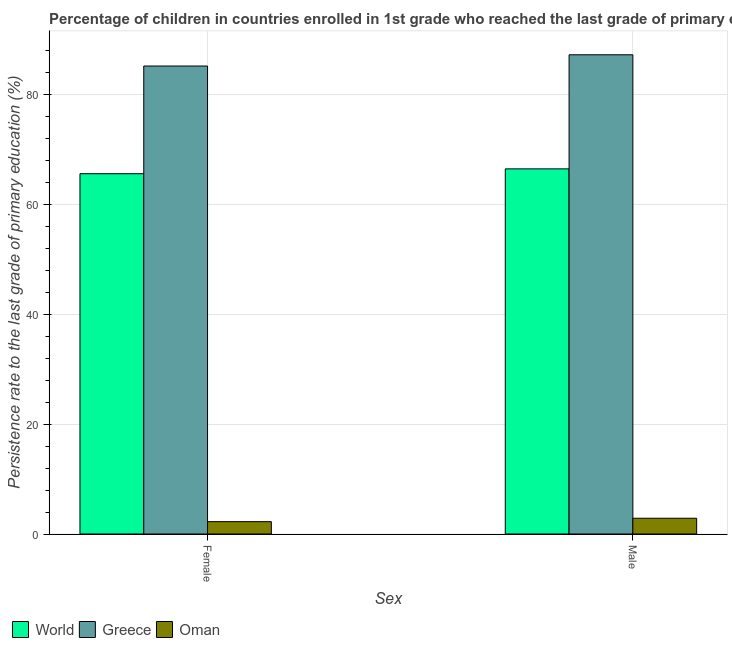Are the number of bars per tick equal to the number of legend labels?
Your answer should be very brief. Yes. Are the number of bars on each tick of the X-axis equal?
Make the answer very short. Yes. What is the persistence rate of female students in World?
Your answer should be very brief. 65.53. Across all countries, what is the maximum persistence rate of female students?
Offer a terse response. 85.11. Across all countries, what is the minimum persistence rate of male students?
Ensure brevity in your answer.  2.87. In which country was the persistence rate of female students minimum?
Give a very brief answer. Oman. What is the total persistence rate of male students in the graph?
Keep it short and to the point. 156.43. What is the difference between the persistence rate of male students in Greece and that in World?
Your response must be concise. 20.75. What is the difference between the persistence rate of male students in Greece and the persistence rate of female students in World?
Keep it short and to the point. 21.63. What is the average persistence rate of male students per country?
Provide a short and direct response. 52.14. What is the difference between the persistence rate of male students and persistence rate of female students in Oman?
Make the answer very short. 0.62. In how many countries, is the persistence rate of female students greater than 72 %?
Keep it short and to the point. 1. What is the ratio of the persistence rate of female students in World to that in Greece?
Offer a very short reply. 0.77. Are all the bars in the graph horizontal?
Offer a very short reply. No. What is the difference between two consecutive major ticks on the Y-axis?
Ensure brevity in your answer.  20. Are the values on the major ticks of Y-axis written in scientific E-notation?
Provide a succinct answer. No. Where does the legend appear in the graph?
Your answer should be very brief. Bottom left. How are the legend labels stacked?
Provide a succinct answer. Horizontal. What is the title of the graph?
Keep it short and to the point. Percentage of children in countries enrolled in 1st grade who reached the last grade of primary education. Does "Cabo Verde" appear as one of the legend labels in the graph?
Offer a very short reply. No. What is the label or title of the X-axis?
Your answer should be compact. Sex. What is the label or title of the Y-axis?
Offer a terse response. Persistence rate to the last grade of primary education (%). What is the Persistence rate to the last grade of primary education (%) of World in Female?
Offer a very short reply. 65.53. What is the Persistence rate to the last grade of primary education (%) in Greece in Female?
Offer a very short reply. 85.11. What is the Persistence rate to the last grade of primary education (%) of Oman in Female?
Offer a terse response. 2.25. What is the Persistence rate to the last grade of primary education (%) in World in Male?
Keep it short and to the point. 66.41. What is the Persistence rate to the last grade of primary education (%) of Greece in Male?
Offer a very short reply. 87.15. What is the Persistence rate to the last grade of primary education (%) in Oman in Male?
Your answer should be very brief. 2.87. Across all Sex, what is the maximum Persistence rate to the last grade of primary education (%) of World?
Offer a very short reply. 66.41. Across all Sex, what is the maximum Persistence rate to the last grade of primary education (%) in Greece?
Provide a short and direct response. 87.15. Across all Sex, what is the maximum Persistence rate to the last grade of primary education (%) of Oman?
Make the answer very short. 2.87. Across all Sex, what is the minimum Persistence rate to the last grade of primary education (%) of World?
Offer a terse response. 65.53. Across all Sex, what is the minimum Persistence rate to the last grade of primary education (%) in Greece?
Your answer should be compact. 85.11. Across all Sex, what is the minimum Persistence rate to the last grade of primary education (%) of Oman?
Your answer should be very brief. 2.25. What is the total Persistence rate to the last grade of primary education (%) in World in the graph?
Provide a succinct answer. 131.93. What is the total Persistence rate to the last grade of primary education (%) of Greece in the graph?
Offer a very short reply. 172.26. What is the total Persistence rate to the last grade of primary education (%) of Oman in the graph?
Keep it short and to the point. 5.11. What is the difference between the Persistence rate to the last grade of primary education (%) in World in Female and that in Male?
Offer a terse response. -0.88. What is the difference between the Persistence rate to the last grade of primary education (%) in Greece in Female and that in Male?
Provide a short and direct response. -2.04. What is the difference between the Persistence rate to the last grade of primary education (%) of Oman in Female and that in Male?
Give a very brief answer. -0.62. What is the difference between the Persistence rate to the last grade of primary education (%) in World in Female and the Persistence rate to the last grade of primary education (%) in Greece in Male?
Offer a terse response. -21.63. What is the difference between the Persistence rate to the last grade of primary education (%) of World in Female and the Persistence rate to the last grade of primary education (%) of Oman in Male?
Ensure brevity in your answer.  62.66. What is the difference between the Persistence rate to the last grade of primary education (%) of Greece in Female and the Persistence rate to the last grade of primary education (%) of Oman in Male?
Offer a very short reply. 82.24. What is the average Persistence rate to the last grade of primary education (%) of World per Sex?
Ensure brevity in your answer.  65.97. What is the average Persistence rate to the last grade of primary education (%) in Greece per Sex?
Your answer should be very brief. 86.13. What is the average Persistence rate to the last grade of primary education (%) of Oman per Sex?
Offer a very short reply. 2.56. What is the difference between the Persistence rate to the last grade of primary education (%) in World and Persistence rate to the last grade of primary education (%) in Greece in Female?
Your answer should be compact. -19.58. What is the difference between the Persistence rate to the last grade of primary education (%) in World and Persistence rate to the last grade of primary education (%) in Oman in Female?
Make the answer very short. 63.28. What is the difference between the Persistence rate to the last grade of primary education (%) of Greece and Persistence rate to the last grade of primary education (%) of Oman in Female?
Offer a very short reply. 82.86. What is the difference between the Persistence rate to the last grade of primary education (%) of World and Persistence rate to the last grade of primary education (%) of Greece in Male?
Keep it short and to the point. -20.75. What is the difference between the Persistence rate to the last grade of primary education (%) of World and Persistence rate to the last grade of primary education (%) of Oman in Male?
Offer a terse response. 63.54. What is the difference between the Persistence rate to the last grade of primary education (%) of Greece and Persistence rate to the last grade of primary education (%) of Oman in Male?
Your answer should be very brief. 84.29. What is the ratio of the Persistence rate to the last grade of primary education (%) of Greece in Female to that in Male?
Your response must be concise. 0.98. What is the ratio of the Persistence rate to the last grade of primary education (%) in Oman in Female to that in Male?
Provide a succinct answer. 0.78. What is the difference between the highest and the second highest Persistence rate to the last grade of primary education (%) of World?
Make the answer very short. 0.88. What is the difference between the highest and the second highest Persistence rate to the last grade of primary education (%) in Greece?
Ensure brevity in your answer.  2.04. What is the difference between the highest and the second highest Persistence rate to the last grade of primary education (%) of Oman?
Offer a very short reply. 0.62. What is the difference between the highest and the lowest Persistence rate to the last grade of primary education (%) of World?
Provide a short and direct response. 0.88. What is the difference between the highest and the lowest Persistence rate to the last grade of primary education (%) of Greece?
Ensure brevity in your answer.  2.04. What is the difference between the highest and the lowest Persistence rate to the last grade of primary education (%) in Oman?
Give a very brief answer. 0.62. 